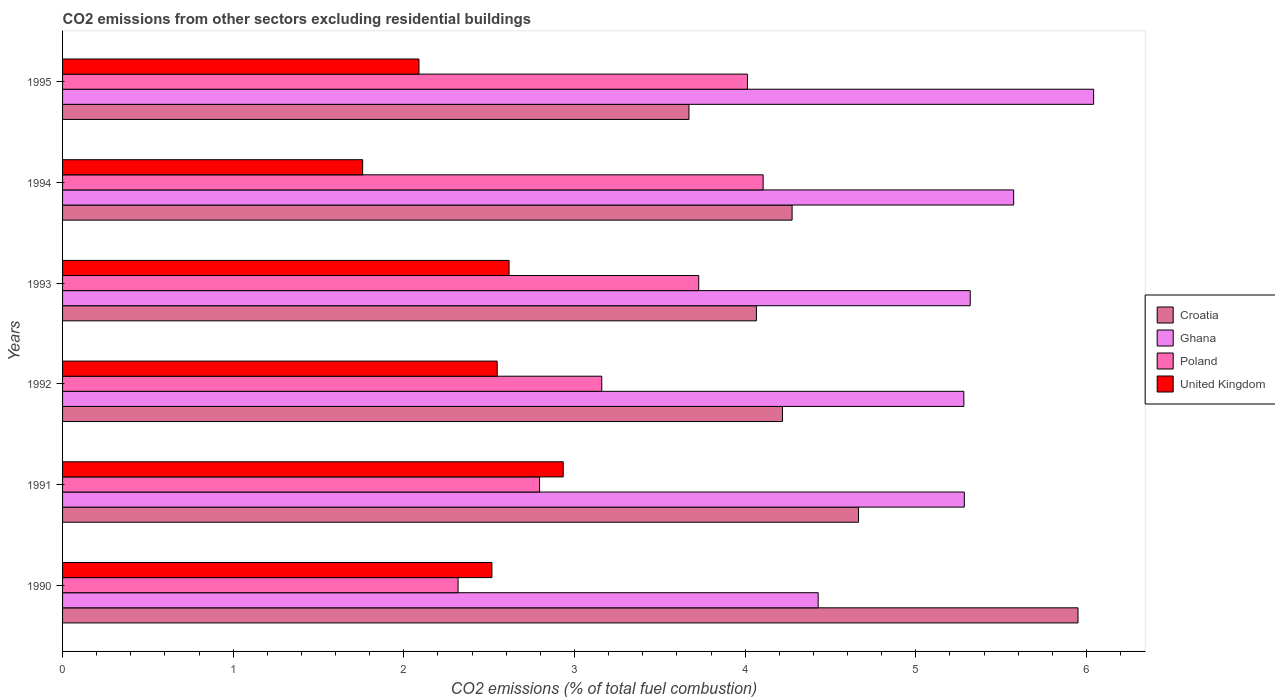How many different coloured bars are there?
Your response must be concise. 4. How many groups of bars are there?
Offer a very short reply. 6. How many bars are there on the 5th tick from the top?
Make the answer very short. 4. How many bars are there on the 4th tick from the bottom?
Offer a very short reply. 4. What is the total CO2 emitted in Ghana in 1992?
Ensure brevity in your answer.  5.28. Across all years, what is the maximum total CO2 emitted in Croatia?
Your answer should be compact. 5.95. Across all years, what is the minimum total CO2 emitted in Ghana?
Offer a very short reply. 4.43. In which year was the total CO2 emitted in Poland minimum?
Keep it short and to the point. 1990. What is the total total CO2 emitted in Ghana in the graph?
Ensure brevity in your answer.  31.93. What is the difference between the total CO2 emitted in Croatia in 1994 and that in 1995?
Your response must be concise. 0.6. What is the difference between the total CO2 emitted in United Kingdom in 1993 and the total CO2 emitted in Ghana in 1992?
Provide a succinct answer. -2.67. What is the average total CO2 emitted in Ghana per year?
Provide a succinct answer. 5.32. In the year 1992, what is the difference between the total CO2 emitted in Croatia and total CO2 emitted in United Kingdom?
Keep it short and to the point. 1.67. What is the ratio of the total CO2 emitted in Poland in 1992 to that in 1995?
Make the answer very short. 0.79. What is the difference between the highest and the second highest total CO2 emitted in Ghana?
Provide a short and direct response. 0.47. What is the difference between the highest and the lowest total CO2 emitted in Ghana?
Provide a succinct answer. 1.61. Is the sum of the total CO2 emitted in Ghana in 1992 and 1995 greater than the maximum total CO2 emitted in Poland across all years?
Make the answer very short. Yes. Is it the case that in every year, the sum of the total CO2 emitted in Poland and total CO2 emitted in Ghana is greater than the sum of total CO2 emitted in United Kingdom and total CO2 emitted in Croatia?
Offer a very short reply. Yes. What does the 4th bar from the top in 1990 represents?
Make the answer very short. Croatia. How many bars are there?
Your answer should be very brief. 24. How many years are there in the graph?
Keep it short and to the point. 6. What is the difference between two consecutive major ticks on the X-axis?
Give a very brief answer. 1. Are the values on the major ticks of X-axis written in scientific E-notation?
Give a very brief answer. No. Where does the legend appear in the graph?
Offer a very short reply. Center right. How are the legend labels stacked?
Give a very brief answer. Vertical. What is the title of the graph?
Keep it short and to the point. CO2 emissions from other sectors excluding residential buildings. What is the label or title of the X-axis?
Provide a succinct answer. CO2 emissions (% of total fuel combustion). What is the CO2 emissions (% of total fuel combustion) of Croatia in 1990?
Offer a terse response. 5.95. What is the CO2 emissions (% of total fuel combustion) in Ghana in 1990?
Provide a short and direct response. 4.43. What is the CO2 emissions (% of total fuel combustion) in Poland in 1990?
Your answer should be compact. 2.32. What is the CO2 emissions (% of total fuel combustion) in United Kingdom in 1990?
Give a very brief answer. 2.52. What is the CO2 emissions (% of total fuel combustion) in Croatia in 1991?
Give a very brief answer. 4.66. What is the CO2 emissions (% of total fuel combustion) of Ghana in 1991?
Your response must be concise. 5.28. What is the CO2 emissions (% of total fuel combustion) of Poland in 1991?
Your response must be concise. 2.8. What is the CO2 emissions (% of total fuel combustion) of United Kingdom in 1991?
Keep it short and to the point. 2.93. What is the CO2 emissions (% of total fuel combustion) of Croatia in 1992?
Provide a short and direct response. 4.22. What is the CO2 emissions (% of total fuel combustion) in Ghana in 1992?
Offer a terse response. 5.28. What is the CO2 emissions (% of total fuel combustion) in Poland in 1992?
Your response must be concise. 3.16. What is the CO2 emissions (% of total fuel combustion) in United Kingdom in 1992?
Ensure brevity in your answer.  2.55. What is the CO2 emissions (% of total fuel combustion) of Croatia in 1993?
Give a very brief answer. 4.07. What is the CO2 emissions (% of total fuel combustion) in Ghana in 1993?
Make the answer very short. 5.32. What is the CO2 emissions (% of total fuel combustion) of Poland in 1993?
Ensure brevity in your answer.  3.73. What is the CO2 emissions (% of total fuel combustion) of United Kingdom in 1993?
Your response must be concise. 2.62. What is the CO2 emissions (% of total fuel combustion) of Croatia in 1994?
Provide a short and direct response. 4.28. What is the CO2 emissions (% of total fuel combustion) in Ghana in 1994?
Offer a very short reply. 5.57. What is the CO2 emissions (% of total fuel combustion) in Poland in 1994?
Your answer should be very brief. 4.11. What is the CO2 emissions (% of total fuel combustion) in United Kingdom in 1994?
Give a very brief answer. 1.76. What is the CO2 emissions (% of total fuel combustion) in Croatia in 1995?
Provide a succinct answer. 3.67. What is the CO2 emissions (% of total fuel combustion) of Ghana in 1995?
Keep it short and to the point. 6.04. What is the CO2 emissions (% of total fuel combustion) in Poland in 1995?
Your answer should be very brief. 4.01. What is the CO2 emissions (% of total fuel combustion) of United Kingdom in 1995?
Ensure brevity in your answer.  2.09. Across all years, what is the maximum CO2 emissions (% of total fuel combustion) in Croatia?
Offer a very short reply. 5.95. Across all years, what is the maximum CO2 emissions (% of total fuel combustion) in Ghana?
Your response must be concise. 6.04. Across all years, what is the maximum CO2 emissions (% of total fuel combustion) of Poland?
Your response must be concise. 4.11. Across all years, what is the maximum CO2 emissions (% of total fuel combustion) in United Kingdom?
Provide a succinct answer. 2.93. Across all years, what is the minimum CO2 emissions (% of total fuel combustion) of Croatia?
Provide a succinct answer. 3.67. Across all years, what is the minimum CO2 emissions (% of total fuel combustion) of Ghana?
Give a very brief answer. 4.43. Across all years, what is the minimum CO2 emissions (% of total fuel combustion) in Poland?
Keep it short and to the point. 2.32. Across all years, what is the minimum CO2 emissions (% of total fuel combustion) in United Kingdom?
Ensure brevity in your answer.  1.76. What is the total CO2 emissions (% of total fuel combustion) of Croatia in the graph?
Provide a short and direct response. 26.85. What is the total CO2 emissions (% of total fuel combustion) in Ghana in the graph?
Make the answer very short. 31.93. What is the total CO2 emissions (% of total fuel combustion) of Poland in the graph?
Keep it short and to the point. 20.12. What is the total CO2 emissions (% of total fuel combustion) of United Kingdom in the graph?
Make the answer very short. 14.46. What is the difference between the CO2 emissions (% of total fuel combustion) of Croatia in 1990 and that in 1991?
Your response must be concise. 1.29. What is the difference between the CO2 emissions (% of total fuel combustion) of Ghana in 1990 and that in 1991?
Offer a terse response. -0.86. What is the difference between the CO2 emissions (% of total fuel combustion) of Poland in 1990 and that in 1991?
Provide a succinct answer. -0.48. What is the difference between the CO2 emissions (% of total fuel combustion) of United Kingdom in 1990 and that in 1991?
Ensure brevity in your answer.  -0.42. What is the difference between the CO2 emissions (% of total fuel combustion) in Croatia in 1990 and that in 1992?
Give a very brief answer. 1.73. What is the difference between the CO2 emissions (% of total fuel combustion) of Ghana in 1990 and that in 1992?
Provide a succinct answer. -0.85. What is the difference between the CO2 emissions (% of total fuel combustion) of Poland in 1990 and that in 1992?
Make the answer very short. -0.84. What is the difference between the CO2 emissions (% of total fuel combustion) of United Kingdom in 1990 and that in 1992?
Your response must be concise. -0.03. What is the difference between the CO2 emissions (% of total fuel combustion) of Croatia in 1990 and that in 1993?
Offer a very short reply. 1.88. What is the difference between the CO2 emissions (% of total fuel combustion) of Ghana in 1990 and that in 1993?
Offer a terse response. -0.89. What is the difference between the CO2 emissions (% of total fuel combustion) of Poland in 1990 and that in 1993?
Your answer should be very brief. -1.41. What is the difference between the CO2 emissions (% of total fuel combustion) of United Kingdom in 1990 and that in 1993?
Ensure brevity in your answer.  -0.1. What is the difference between the CO2 emissions (% of total fuel combustion) of Croatia in 1990 and that in 1994?
Provide a succinct answer. 1.68. What is the difference between the CO2 emissions (% of total fuel combustion) of Ghana in 1990 and that in 1994?
Your response must be concise. -1.15. What is the difference between the CO2 emissions (% of total fuel combustion) of Poland in 1990 and that in 1994?
Offer a very short reply. -1.79. What is the difference between the CO2 emissions (% of total fuel combustion) in United Kingdom in 1990 and that in 1994?
Your answer should be compact. 0.76. What is the difference between the CO2 emissions (% of total fuel combustion) in Croatia in 1990 and that in 1995?
Offer a terse response. 2.28. What is the difference between the CO2 emissions (% of total fuel combustion) of Ghana in 1990 and that in 1995?
Keep it short and to the point. -1.61. What is the difference between the CO2 emissions (% of total fuel combustion) of Poland in 1990 and that in 1995?
Ensure brevity in your answer.  -1.7. What is the difference between the CO2 emissions (% of total fuel combustion) of United Kingdom in 1990 and that in 1995?
Give a very brief answer. 0.43. What is the difference between the CO2 emissions (% of total fuel combustion) in Croatia in 1991 and that in 1992?
Your response must be concise. 0.45. What is the difference between the CO2 emissions (% of total fuel combustion) in Ghana in 1991 and that in 1992?
Offer a terse response. 0. What is the difference between the CO2 emissions (% of total fuel combustion) in Poland in 1991 and that in 1992?
Offer a terse response. -0.36. What is the difference between the CO2 emissions (% of total fuel combustion) of United Kingdom in 1991 and that in 1992?
Offer a very short reply. 0.39. What is the difference between the CO2 emissions (% of total fuel combustion) of Croatia in 1991 and that in 1993?
Ensure brevity in your answer.  0.6. What is the difference between the CO2 emissions (% of total fuel combustion) in Ghana in 1991 and that in 1993?
Provide a succinct answer. -0.03. What is the difference between the CO2 emissions (% of total fuel combustion) in Poland in 1991 and that in 1993?
Your answer should be compact. -0.93. What is the difference between the CO2 emissions (% of total fuel combustion) in United Kingdom in 1991 and that in 1993?
Offer a terse response. 0.32. What is the difference between the CO2 emissions (% of total fuel combustion) of Croatia in 1991 and that in 1994?
Your response must be concise. 0.39. What is the difference between the CO2 emissions (% of total fuel combustion) in Ghana in 1991 and that in 1994?
Provide a short and direct response. -0.29. What is the difference between the CO2 emissions (% of total fuel combustion) in Poland in 1991 and that in 1994?
Offer a terse response. -1.31. What is the difference between the CO2 emissions (% of total fuel combustion) in United Kingdom in 1991 and that in 1994?
Your response must be concise. 1.18. What is the difference between the CO2 emissions (% of total fuel combustion) in Croatia in 1991 and that in 1995?
Your answer should be compact. 0.99. What is the difference between the CO2 emissions (% of total fuel combustion) of Ghana in 1991 and that in 1995?
Offer a terse response. -0.76. What is the difference between the CO2 emissions (% of total fuel combustion) in Poland in 1991 and that in 1995?
Your answer should be compact. -1.22. What is the difference between the CO2 emissions (% of total fuel combustion) of United Kingdom in 1991 and that in 1995?
Provide a succinct answer. 0.85. What is the difference between the CO2 emissions (% of total fuel combustion) of Croatia in 1992 and that in 1993?
Keep it short and to the point. 0.15. What is the difference between the CO2 emissions (% of total fuel combustion) in Ghana in 1992 and that in 1993?
Your answer should be very brief. -0.04. What is the difference between the CO2 emissions (% of total fuel combustion) of Poland in 1992 and that in 1993?
Give a very brief answer. -0.57. What is the difference between the CO2 emissions (% of total fuel combustion) in United Kingdom in 1992 and that in 1993?
Offer a terse response. -0.07. What is the difference between the CO2 emissions (% of total fuel combustion) of Croatia in 1992 and that in 1994?
Your answer should be compact. -0.06. What is the difference between the CO2 emissions (% of total fuel combustion) of Ghana in 1992 and that in 1994?
Provide a short and direct response. -0.29. What is the difference between the CO2 emissions (% of total fuel combustion) of Poland in 1992 and that in 1994?
Give a very brief answer. -0.95. What is the difference between the CO2 emissions (% of total fuel combustion) in United Kingdom in 1992 and that in 1994?
Your response must be concise. 0.79. What is the difference between the CO2 emissions (% of total fuel combustion) of Croatia in 1992 and that in 1995?
Provide a succinct answer. 0.55. What is the difference between the CO2 emissions (% of total fuel combustion) of Ghana in 1992 and that in 1995?
Your answer should be very brief. -0.76. What is the difference between the CO2 emissions (% of total fuel combustion) in Poland in 1992 and that in 1995?
Provide a succinct answer. -0.85. What is the difference between the CO2 emissions (% of total fuel combustion) in United Kingdom in 1992 and that in 1995?
Make the answer very short. 0.46. What is the difference between the CO2 emissions (% of total fuel combustion) in Croatia in 1993 and that in 1994?
Ensure brevity in your answer.  -0.21. What is the difference between the CO2 emissions (% of total fuel combustion) of Ghana in 1993 and that in 1994?
Give a very brief answer. -0.25. What is the difference between the CO2 emissions (% of total fuel combustion) in Poland in 1993 and that in 1994?
Keep it short and to the point. -0.38. What is the difference between the CO2 emissions (% of total fuel combustion) in United Kingdom in 1993 and that in 1994?
Offer a terse response. 0.86. What is the difference between the CO2 emissions (% of total fuel combustion) of Croatia in 1993 and that in 1995?
Keep it short and to the point. 0.4. What is the difference between the CO2 emissions (% of total fuel combustion) of Ghana in 1993 and that in 1995?
Keep it short and to the point. -0.72. What is the difference between the CO2 emissions (% of total fuel combustion) in Poland in 1993 and that in 1995?
Ensure brevity in your answer.  -0.29. What is the difference between the CO2 emissions (% of total fuel combustion) in United Kingdom in 1993 and that in 1995?
Your response must be concise. 0.53. What is the difference between the CO2 emissions (% of total fuel combustion) of Croatia in 1994 and that in 1995?
Make the answer very short. 0.6. What is the difference between the CO2 emissions (% of total fuel combustion) in Ghana in 1994 and that in 1995?
Your response must be concise. -0.47. What is the difference between the CO2 emissions (% of total fuel combustion) in Poland in 1994 and that in 1995?
Make the answer very short. 0.09. What is the difference between the CO2 emissions (% of total fuel combustion) in United Kingdom in 1994 and that in 1995?
Your response must be concise. -0.33. What is the difference between the CO2 emissions (% of total fuel combustion) of Croatia in 1990 and the CO2 emissions (% of total fuel combustion) of Ghana in 1991?
Keep it short and to the point. 0.67. What is the difference between the CO2 emissions (% of total fuel combustion) in Croatia in 1990 and the CO2 emissions (% of total fuel combustion) in Poland in 1991?
Offer a terse response. 3.16. What is the difference between the CO2 emissions (% of total fuel combustion) in Croatia in 1990 and the CO2 emissions (% of total fuel combustion) in United Kingdom in 1991?
Give a very brief answer. 3.02. What is the difference between the CO2 emissions (% of total fuel combustion) of Ghana in 1990 and the CO2 emissions (% of total fuel combustion) of Poland in 1991?
Your answer should be compact. 1.63. What is the difference between the CO2 emissions (% of total fuel combustion) in Ghana in 1990 and the CO2 emissions (% of total fuel combustion) in United Kingdom in 1991?
Give a very brief answer. 1.49. What is the difference between the CO2 emissions (% of total fuel combustion) in Poland in 1990 and the CO2 emissions (% of total fuel combustion) in United Kingdom in 1991?
Your answer should be very brief. -0.62. What is the difference between the CO2 emissions (% of total fuel combustion) of Croatia in 1990 and the CO2 emissions (% of total fuel combustion) of Ghana in 1992?
Keep it short and to the point. 0.67. What is the difference between the CO2 emissions (% of total fuel combustion) in Croatia in 1990 and the CO2 emissions (% of total fuel combustion) in Poland in 1992?
Provide a short and direct response. 2.79. What is the difference between the CO2 emissions (% of total fuel combustion) in Croatia in 1990 and the CO2 emissions (% of total fuel combustion) in United Kingdom in 1992?
Your answer should be compact. 3.4. What is the difference between the CO2 emissions (% of total fuel combustion) in Ghana in 1990 and the CO2 emissions (% of total fuel combustion) in Poland in 1992?
Your answer should be very brief. 1.27. What is the difference between the CO2 emissions (% of total fuel combustion) of Ghana in 1990 and the CO2 emissions (% of total fuel combustion) of United Kingdom in 1992?
Offer a terse response. 1.88. What is the difference between the CO2 emissions (% of total fuel combustion) in Poland in 1990 and the CO2 emissions (% of total fuel combustion) in United Kingdom in 1992?
Ensure brevity in your answer.  -0.23. What is the difference between the CO2 emissions (% of total fuel combustion) in Croatia in 1990 and the CO2 emissions (% of total fuel combustion) in Ghana in 1993?
Provide a short and direct response. 0.63. What is the difference between the CO2 emissions (% of total fuel combustion) of Croatia in 1990 and the CO2 emissions (% of total fuel combustion) of Poland in 1993?
Provide a succinct answer. 2.22. What is the difference between the CO2 emissions (% of total fuel combustion) in Croatia in 1990 and the CO2 emissions (% of total fuel combustion) in United Kingdom in 1993?
Keep it short and to the point. 3.33. What is the difference between the CO2 emissions (% of total fuel combustion) of Ghana in 1990 and the CO2 emissions (% of total fuel combustion) of United Kingdom in 1993?
Your answer should be very brief. 1.81. What is the difference between the CO2 emissions (% of total fuel combustion) of Poland in 1990 and the CO2 emissions (% of total fuel combustion) of United Kingdom in 1993?
Your response must be concise. -0.3. What is the difference between the CO2 emissions (% of total fuel combustion) in Croatia in 1990 and the CO2 emissions (% of total fuel combustion) in Ghana in 1994?
Offer a terse response. 0.38. What is the difference between the CO2 emissions (% of total fuel combustion) in Croatia in 1990 and the CO2 emissions (% of total fuel combustion) in Poland in 1994?
Provide a succinct answer. 1.84. What is the difference between the CO2 emissions (% of total fuel combustion) in Croatia in 1990 and the CO2 emissions (% of total fuel combustion) in United Kingdom in 1994?
Ensure brevity in your answer.  4.19. What is the difference between the CO2 emissions (% of total fuel combustion) in Ghana in 1990 and the CO2 emissions (% of total fuel combustion) in Poland in 1994?
Provide a succinct answer. 0.32. What is the difference between the CO2 emissions (% of total fuel combustion) of Ghana in 1990 and the CO2 emissions (% of total fuel combustion) of United Kingdom in 1994?
Give a very brief answer. 2.67. What is the difference between the CO2 emissions (% of total fuel combustion) of Poland in 1990 and the CO2 emissions (% of total fuel combustion) of United Kingdom in 1994?
Offer a terse response. 0.56. What is the difference between the CO2 emissions (% of total fuel combustion) of Croatia in 1990 and the CO2 emissions (% of total fuel combustion) of Ghana in 1995?
Make the answer very short. -0.09. What is the difference between the CO2 emissions (% of total fuel combustion) of Croatia in 1990 and the CO2 emissions (% of total fuel combustion) of Poland in 1995?
Provide a succinct answer. 1.94. What is the difference between the CO2 emissions (% of total fuel combustion) of Croatia in 1990 and the CO2 emissions (% of total fuel combustion) of United Kingdom in 1995?
Keep it short and to the point. 3.86. What is the difference between the CO2 emissions (% of total fuel combustion) in Ghana in 1990 and the CO2 emissions (% of total fuel combustion) in Poland in 1995?
Provide a succinct answer. 0.41. What is the difference between the CO2 emissions (% of total fuel combustion) of Ghana in 1990 and the CO2 emissions (% of total fuel combustion) of United Kingdom in 1995?
Your answer should be very brief. 2.34. What is the difference between the CO2 emissions (% of total fuel combustion) of Poland in 1990 and the CO2 emissions (% of total fuel combustion) of United Kingdom in 1995?
Offer a terse response. 0.23. What is the difference between the CO2 emissions (% of total fuel combustion) in Croatia in 1991 and the CO2 emissions (% of total fuel combustion) in Ghana in 1992?
Your answer should be very brief. -0.62. What is the difference between the CO2 emissions (% of total fuel combustion) in Croatia in 1991 and the CO2 emissions (% of total fuel combustion) in Poland in 1992?
Your answer should be compact. 1.5. What is the difference between the CO2 emissions (% of total fuel combustion) of Croatia in 1991 and the CO2 emissions (% of total fuel combustion) of United Kingdom in 1992?
Provide a short and direct response. 2.12. What is the difference between the CO2 emissions (% of total fuel combustion) in Ghana in 1991 and the CO2 emissions (% of total fuel combustion) in Poland in 1992?
Make the answer very short. 2.12. What is the difference between the CO2 emissions (% of total fuel combustion) in Ghana in 1991 and the CO2 emissions (% of total fuel combustion) in United Kingdom in 1992?
Offer a very short reply. 2.74. What is the difference between the CO2 emissions (% of total fuel combustion) of Poland in 1991 and the CO2 emissions (% of total fuel combustion) of United Kingdom in 1992?
Ensure brevity in your answer.  0.25. What is the difference between the CO2 emissions (% of total fuel combustion) of Croatia in 1991 and the CO2 emissions (% of total fuel combustion) of Ghana in 1993?
Ensure brevity in your answer.  -0.65. What is the difference between the CO2 emissions (% of total fuel combustion) in Croatia in 1991 and the CO2 emissions (% of total fuel combustion) in Poland in 1993?
Make the answer very short. 0.94. What is the difference between the CO2 emissions (% of total fuel combustion) of Croatia in 1991 and the CO2 emissions (% of total fuel combustion) of United Kingdom in 1993?
Provide a succinct answer. 2.05. What is the difference between the CO2 emissions (% of total fuel combustion) in Ghana in 1991 and the CO2 emissions (% of total fuel combustion) in Poland in 1993?
Keep it short and to the point. 1.56. What is the difference between the CO2 emissions (% of total fuel combustion) in Ghana in 1991 and the CO2 emissions (% of total fuel combustion) in United Kingdom in 1993?
Offer a very short reply. 2.67. What is the difference between the CO2 emissions (% of total fuel combustion) in Poland in 1991 and the CO2 emissions (% of total fuel combustion) in United Kingdom in 1993?
Offer a very short reply. 0.18. What is the difference between the CO2 emissions (% of total fuel combustion) in Croatia in 1991 and the CO2 emissions (% of total fuel combustion) in Ghana in 1994?
Your answer should be very brief. -0.91. What is the difference between the CO2 emissions (% of total fuel combustion) in Croatia in 1991 and the CO2 emissions (% of total fuel combustion) in Poland in 1994?
Provide a short and direct response. 0.56. What is the difference between the CO2 emissions (% of total fuel combustion) of Croatia in 1991 and the CO2 emissions (% of total fuel combustion) of United Kingdom in 1994?
Your answer should be very brief. 2.91. What is the difference between the CO2 emissions (% of total fuel combustion) in Ghana in 1991 and the CO2 emissions (% of total fuel combustion) in Poland in 1994?
Make the answer very short. 1.18. What is the difference between the CO2 emissions (% of total fuel combustion) of Ghana in 1991 and the CO2 emissions (% of total fuel combustion) of United Kingdom in 1994?
Your answer should be compact. 3.53. What is the difference between the CO2 emissions (% of total fuel combustion) in Poland in 1991 and the CO2 emissions (% of total fuel combustion) in United Kingdom in 1994?
Make the answer very short. 1.04. What is the difference between the CO2 emissions (% of total fuel combustion) of Croatia in 1991 and the CO2 emissions (% of total fuel combustion) of Ghana in 1995?
Your response must be concise. -1.38. What is the difference between the CO2 emissions (% of total fuel combustion) in Croatia in 1991 and the CO2 emissions (% of total fuel combustion) in Poland in 1995?
Provide a short and direct response. 0.65. What is the difference between the CO2 emissions (% of total fuel combustion) in Croatia in 1991 and the CO2 emissions (% of total fuel combustion) in United Kingdom in 1995?
Your answer should be very brief. 2.58. What is the difference between the CO2 emissions (% of total fuel combustion) in Ghana in 1991 and the CO2 emissions (% of total fuel combustion) in Poland in 1995?
Provide a succinct answer. 1.27. What is the difference between the CO2 emissions (% of total fuel combustion) in Ghana in 1991 and the CO2 emissions (% of total fuel combustion) in United Kingdom in 1995?
Give a very brief answer. 3.2. What is the difference between the CO2 emissions (% of total fuel combustion) of Poland in 1991 and the CO2 emissions (% of total fuel combustion) of United Kingdom in 1995?
Provide a succinct answer. 0.71. What is the difference between the CO2 emissions (% of total fuel combustion) of Croatia in 1992 and the CO2 emissions (% of total fuel combustion) of Ghana in 1993?
Give a very brief answer. -1.1. What is the difference between the CO2 emissions (% of total fuel combustion) of Croatia in 1992 and the CO2 emissions (% of total fuel combustion) of Poland in 1993?
Offer a terse response. 0.49. What is the difference between the CO2 emissions (% of total fuel combustion) of Croatia in 1992 and the CO2 emissions (% of total fuel combustion) of United Kingdom in 1993?
Keep it short and to the point. 1.6. What is the difference between the CO2 emissions (% of total fuel combustion) of Ghana in 1992 and the CO2 emissions (% of total fuel combustion) of Poland in 1993?
Your response must be concise. 1.55. What is the difference between the CO2 emissions (% of total fuel combustion) of Ghana in 1992 and the CO2 emissions (% of total fuel combustion) of United Kingdom in 1993?
Make the answer very short. 2.67. What is the difference between the CO2 emissions (% of total fuel combustion) in Poland in 1992 and the CO2 emissions (% of total fuel combustion) in United Kingdom in 1993?
Your response must be concise. 0.54. What is the difference between the CO2 emissions (% of total fuel combustion) of Croatia in 1992 and the CO2 emissions (% of total fuel combustion) of Ghana in 1994?
Offer a terse response. -1.35. What is the difference between the CO2 emissions (% of total fuel combustion) in Croatia in 1992 and the CO2 emissions (% of total fuel combustion) in Poland in 1994?
Your answer should be compact. 0.11. What is the difference between the CO2 emissions (% of total fuel combustion) of Croatia in 1992 and the CO2 emissions (% of total fuel combustion) of United Kingdom in 1994?
Offer a very short reply. 2.46. What is the difference between the CO2 emissions (% of total fuel combustion) of Ghana in 1992 and the CO2 emissions (% of total fuel combustion) of Poland in 1994?
Your answer should be very brief. 1.18. What is the difference between the CO2 emissions (% of total fuel combustion) of Ghana in 1992 and the CO2 emissions (% of total fuel combustion) of United Kingdom in 1994?
Your answer should be very brief. 3.52. What is the difference between the CO2 emissions (% of total fuel combustion) of Poland in 1992 and the CO2 emissions (% of total fuel combustion) of United Kingdom in 1994?
Your answer should be very brief. 1.4. What is the difference between the CO2 emissions (% of total fuel combustion) in Croatia in 1992 and the CO2 emissions (% of total fuel combustion) in Ghana in 1995?
Your answer should be compact. -1.82. What is the difference between the CO2 emissions (% of total fuel combustion) of Croatia in 1992 and the CO2 emissions (% of total fuel combustion) of Poland in 1995?
Keep it short and to the point. 0.21. What is the difference between the CO2 emissions (% of total fuel combustion) in Croatia in 1992 and the CO2 emissions (% of total fuel combustion) in United Kingdom in 1995?
Make the answer very short. 2.13. What is the difference between the CO2 emissions (% of total fuel combustion) of Ghana in 1992 and the CO2 emissions (% of total fuel combustion) of Poland in 1995?
Ensure brevity in your answer.  1.27. What is the difference between the CO2 emissions (% of total fuel combustion) in Ghana in 1992 and the CO2 emissions (% of total fuel combustion) in United Kingdom in 1995?
Offer a terse response. 3.19. What is the difference between the CO2 emissions (% of total fuel combustion) in Poland in 1992 and the CO2 emissions (% of total fuel combustion) in United Kingdom in 1995?
Offer a very short reply. 1.07. What is the difference between the CO2 emissions (% of total fuel combustion) in Croatia in 1993 and the CO2 emissions (% of total fuel combustion) in Ghana in 1994?
Give a very brief answer. -1.51. What is the difference between the CO2 emissions (% of total fuel combustion) of Croatia in 1993 and the CO2 emissions (% of total fuel combustion) of Poland in 1994?
Offer a terse response. -0.04. What is the difference between the CO2 emissions (% of total fuel combustion) of Croatia in 1993 and the CO2 emissions (% of total fuel combustion) of United Kingdom in 1994?
Provide a succinct answer. 2.31. What is the difference between the CO2 emissions (% of total fuel combustion) of Ghana in 1993 and the CO2 emissions (% of total fuel combustion) of Poland in 1994?
Provide a short and direct response. 1.21. What is the difference between the CO2 emissions (% of total fuel combustion) in Ghana in 1993 and the CO2 emissions (% of total fuel combustion) in United Kingdom in 1994?
Provide a succinct answer. 3.56. What is the difference between the CO2 emissions (% of total fuel combustion) in Poland in 1993 and the CO2 emissions (% of total fuel combustion) in United Kingdom in 1994?
Your answer should be very brief. 1.97. What is the difference between the CO2 emissions (% of total fuel combustion) of Croatia in 1993 and the CO2 emissions (% of total fuel combustion) of Ghana in 1995?
Your response must be concise. -1.98. What is the difference between the CO2 emissions (% of total fuel combustion) in Croatia in 1993 and the CO2 emissions (% of total fuel combustion) in Poland in 1995?
Provide a short and direct response. 0.05. What is the difference between the CO2 emissions (% of total fuel combustion) in Croatia in 1993 and the CO2 emissions (% of total fuel combustion) in United Kingdom in 1995?
Keep it short and to the point. 1.98. What is the difference between the CO2 emissions (% of total fuel combustion) in Ghana in 1993 and the CO2 emissions (% of total fuel combustion) in Poland in 1995?
Your response must be concise. 1.31. What is the difference between the CO2 emissions (% of total fuel combustion) in Ghana in 1993 and the CO2 emissions (% of total fuel combustion) in United Kingdom in 1995?
Make the answer very short. 3.23. What is the difference between the CO2 emissions (% of total fuel combustion) of Poland in 1993 and the CO2 emissions (% of total fuel combustion) of United Kingdom in 1995?
Provide a succinct answer. 1.64. What is the difference between the CO2 emissions (% of total fuel combustion) in Croatia in 1994 and the CO2 emissions (% of total fuel combustion) in Ghana in 1995?
Your answer should be very brief. -1.77. What is the difference between the CO2 emissions (% of total fuel combustion) of Croatia in 1994 and the CO2 emissions (% of total fuel combustion) of Poland in 1995?
Ensure brevity in your answer.  0.26. What is the difference between the CO2 emissions (% of total fuel combustion) of Croatia in 1994 and the CO2 emissions (% of total fuel combustion) of United Kingdom in 1995?
Give a very brief answer. 2.19. What is the difference between the CO2 emissions (% of total fuel combustion) in Ghana in 1994 and the CO2 emissions (% of total fuel combustion) in Poland in 1995?
Provide a short and direct response. 1.56. What is the difference between the CO2 emissions (% of total fuel combustion) in Ghana in 1994 and the CO2 emissions (% of total fuel combustion) in United Kingdom in 1995?
Keep it short and to the point. 3.49. What is the difference between the CO2 emissions (% of total fuel combustion) in Poland in 1994 and the CO2 emissions (% of total fuel combustion) in United Kingdom in 1995?
Offer a terse response. 2.02. What is the average CO2 emissions (% of total fuel combustion) in Croatia per year?
Your answer should be very brief. 4.47. What is the average CO2 emissions (% of total fuel combustion) of Ghana per year?
Your answer should be very brief. 5.32. What is the average CO2 emissions (% of total fuel combustion) of Poland per year?
Your answer should be very brief. 3.35. What is the average CO2 emissions (% of total fuel combustion) in United Kingdom per year?
Make the answer very short. 2.41. In the year 1990, what is the difference between the CO2 emissions (% of total fuel combustion) in Croatia and CO2 emissions (% of total fuel combustion) in Ghana?
Make the answer very short. 1.52. In the year 1990, what is the difference between the CO2 emissions (% of total fuel combustion) in Croatia and CO2 emissions (% of total fuel combustion) in Poland?
Give a very brief answer. 3.63. In the year 1990, what is the difference between the CO2 emissions (% of total fuel combustion) in Croatia and CO2 emissions (% of total fuel combustion) in United Kingdom?
Keep it short and to the point. 3.43. In the year 1990, what is the difference between the CO2 emissions (% of total fuel combustion) of Ghana and CO2 emissions (% of total fuel combustion) of Poland?
Give a very brief answer. 2.11. In the year 1990, what is the difference between the CO2 emissions (% of total fuel combustion) of Ghana and CO2 emissions (% of total fuel combustion) of United Kingdom?
Provide a short and direct response. 1.91. In the year 1990, what is the difference between the CO2 emissions (% of total fuel combustion) in Poland and CO2 emissions (% of total fuel combustion) in United Kingdom?
Your answer should be compact. -0.2. In the year 1991, what is the difference between the CO2 emissions (% of total fuel combustion) in Croatia and CO2 emissions (% of total fuel combustion) in Ghana?
Provide a short and direct response. -0.62. In the year 1991, what is the difference between the CO2 emissions (% of total fuel combustion) in Croatia and CO2 emissions (% of total fuel combustion) in Poland?
Offer a very short reply. 1.87. In the year 1991, what is the difference between the CO2 emissions (% of total fuel combustion) in Croatia and CO2 emissions (% of total fuel combustion) in United Kingdom?
Your answer should be very brief. 1.73. In the year 1991, what is the difference between the CO2 emissions (% of total fuel combustion) in Ghana and CO2 emissions (% of total fuel combustion) in Poland?
Your answer should be compact. 2.49. In the year 1991, what is the difference between the CO2 emissions (% of total fuel combustion) of Ghana and CO2 emissions (% of total fuel combustion) of United Kingdom?
Provide a short and direct response. 2.35. In the year 1991, what is the difference between the CO2 emissions (% of total fuel combustion) of Poland and CO2 emissions (% of total fuel combustion) of United Kingdom?
Give a very brief answer. -0.14. In the year 1992, what is the difference between the CO2 emissions (% of total fuel combustion) in Croatia and CO2 emissions (% of total fuel combustion) in Ghana?
Keep it short and to the point. -1.06. In the year 1992, what is the difference between the CO2 emissions (% of total fuel combustion) of Croatia and CO2 emissions (% of total fuel combustion) of Poland?
Provide a short and direct response. 1.06. In the year 1992, what is the difference between the CO2 emissions (% of total fuel combustion) in Croatia and CO2 emissions (% of total fuel combustion) in United Kingdom?
Your answer should be very brief. 1.67. In the year 1992, what is the difference between the CO2 emissions (% of total fuel combustion) in Ghana and CO2 emissions (% of total fuel combustion) in Poland?
Keep it short and to the point. 2.12. In the year 1992, what is the difference between the CO2 emissions (% of total fuel combustion) of Ghana and CO2 emissions (% of total fuel combustion) of United Kingdom?
Your response must be concise. 2.73. In the year 1992, what is the difference between the CO2 emissions (% of total fuel combustion) in Poland and CO2 emissions (% of total fuel combustion) in United Kingdom?
Keep it short and to the point. 0.61. In the year 1993, what is the difference between the CO2 emissions (% of total fuel combustion) in Croatia and CO2 emissions (% of total fuel combustion) in Ghana?
Keep it short and to the point. -1.25. In the year 1993, what is the difference between the CO2 emissions (% of total fuel combustion) of Croatia and CO2 emissions (% of total fuel combustion) of Poland?
Your answer should be compact. 0.34. In the year 1993, what is the difference between the CO2 emissions (% of total fuel combustion) of Croatia and CO2 emissions (% of total fuel combustion) of United Kingdom?
Provide a short and direct response. 1.45. In the year 1993, what is the difference between the CO2 emissions (% of total fuel combustion) of Ghana and CO2 emissions (% of total fuel combustion) of Poland?
Make the answer very short. 1.59. In the year 1993, what is the difference between the CO2 emissions (% of total fuel combustion) in Ghana and CO2 emissions (% of total fuel combustion) in United Kingdom?
Give a very brief answer. 2.7. In the year 1993, what is the difference between the CO2 emissions (% of total fuel combustion) of Poland and CO2 emissions (% of total fuel combustion) of United Kingdom?
Ensure brevity in your answer.  1.11. In the year 1994, what is the difference between the CO2 emissions (% of total fuel combustion) of Croatia and CO2 emissions (% of total fuel combustion) of Ghana?
Make the answer very short. -1.3. In the year 1994, what is the difference between the CO2 emissions (% of total fuel combustion) in Croatia and CO2 emissions (% of total fuel combustion) in Poland?
Keep it short and to the point. 0.17. In the year 1994, what is the difference between the CO2 emissions (% of total fuel combustion) in Croatia and CO2 emissions (% of total fuel combustion) in United Kingdom?
Offer a very short reply. 2.52. In the year 1994, what is the difference between the CO2 emissions (% of total fuel combustion) in Ghana and CO2 emissions (% of total fuel combustion) in Poland?
Make the answer very short. 1.47. In the year 1994, what is the difference between the CO2 emissions (% of total fuel combustion) of Ghana and CO2 emissions (% of total fuel combustion) of United Kingdom?
Your answer should be compact. 3.82. In the year 1994, what is the difference between the CO2 emissions (% of total fuel combustion) of Poland and CO2 emissions (% of total fuel combustion) of United Kingdom?
Your response must be concise. 2.35. In the year 1995, what is the difference between the CO2 emissions (% of total fuel combustion) of Croatia and CO2 emissions (% of total fuel combustion) of Ghana?
Make the answer very short. -2.37. In the year 1995, what is the difference between the CO2 emissions (% of total fuel combustion) of Croatia and CO2 emissions (% of total fuel combustion) of Poland?
Your response must be concise. -0.34. In the year 1995, what is the difference between the CO2 emissions (% of total fuel combustion) in Croatia and CO2 emissions (% of total fuel combustion) in United Kingdom?
Make the answer very short. 1.58. In the year 1995, what is the difference between the CO2 emissions (% of total fuel combustion) in Ghana and CO2 emissions (% of total fuel combustion) in Poland?
Your answer should be very brief. 2.03. In the year 1995, what is the difference between the CO2 emissions (% of total fuel combustion) in Ghana and CO2 emissions (% of total fuel combustion) in United Kingdom?
Offer a terse response. 3.95. In the year 1995, what is the difference between the CO2 emissions (% of total fuel combustion) of Poland and CO2 emissions (% of total fuel combustion) of United Kingdom?
Offer a terse response. 1.92. What is the ratio of the CO2 emissions (% of total fuel combustion) in Croatia in 1990 to that in 1991?
Provide a short and direct response. 1.28. What is the ratio of the CO2 emissions (% of total fuel combustion) of Ghana in 1990 to that in 1991?
Provide a short and direct response. 0.84. What is the ratio of the CO2 emissions (% of total fuel combustion) in Poland in 1990 to that in 1991?
Provide a short and direct response. 0.83. What is the ratio of the CO2 emissions (% of total fuel combustion) in United Kingdom in 1990 to that in 1991?
Your response must be concise. 0.86. What is the ratio of the CO2 emissions (% of total fuel combustion) in Croatia in 1990 to that in 1992?
Make the answer very short. 1.41. What is the ratio of the CO2 emissions (% of total fuel combustion) in Ghana in 1990 to that in 1992?
Your answer should be compact. 0.84. What is the ratio of the CO2 emissions (% of total fuel combustion) in Poland in 1990 to that in 1992?
Your response must be concise. 0.73. What is the ratio of the CO2 emissions (% of total fuel combustion) of United Kingdom in 1990 to that in 1992?
Your answer should be compact. 0.99. What is the ratio of the CO2 emissions (% of total fuel combustion) of Croatia in 1990 to that in 1993?
Your answer should be compact. 1.46. What is the ratio of the CO2 emissions (% of total fuel combustion) of Ghana in 1990 to that in 1993?
Offer a terse response. 0.83. What is the ratio of the CO2 emissions (% of total fuel combustion) in Poland in 1990 to that in 1993?
Provide a succinct answer. 0.62. What is the ratio of the CO2 emissions (% of total fuel combustion) in United Kingdom in 1990 to that in 1993?
Ensure brevity in your answer.  0.96. What is the ratio of the CO2 emissions (% of total fuel combustion) of Croatia in 1990 to that in 1994?
Keep it short and to the point. 1.39. What is the ratio of the CO2 emissions (% of total fuel combustion) of Ghana in 1990 to that in 1994?
Ensure brevity in your answer.  0.79. What is the ratio of the CO2 emissions (% of total fuel combustion) of Poland in 1990 to that in 1994?
Offer a terse response. 0.56. What is the ratio of the CO2 emissions (% of total fuel combustion) in United Kingdom in 1990 to that in 1994?
Your response must be concise. 1.43. What is the ratio of the CO2 emissions (% of total fuel combustion) of Croatia in 1990 to that in 1995?
Your answer should be very brief. 1.62. What is the ratio of the CO2 emissions (% of total fuel combustion) in Ghana in 1990 to that in 1995?
Your response must be concise. 0.73. What is the ratio of the CO2 emissions (% of total fuel combustion) of Poland in 1990 to that in 1995?
Keep it short and to the point. 0.58. What is the ratio of the CO2 emissions (% of total fuel combustion) in United Kingdom in 1990 to that in 1995?
Keep it short and to the point. 1.2. What is the ratio of the CO2 emissions (% of total fuel combustion) of Croatia in 1991 to that in 1992?
Your answer should be compact. 1.11. What is the ratio of the CO2 emissions (% of total fuel combustion) of Ghana in 1991 to that in 1992?
Make the answer very short. 1. What is the ratio of the CO2 emissions (% of total fuel combustion) in Poland in 1991 to that in 1992?
Ensure brevity in your answer.  0.88. What is the ratio of the CO2 emissions (% of total fuel combustion) of United Kingdom in 1991 to that in 1992?
Keep it short and to the point. 1.15. What is the ratio of the CO2 emissions (% of total fuel combustion) of Croatia in 1991 to that in 1993?
Your answer should be compact. 1.15. What is the ratio of the CO2 emissions (% of total fuel combustion) of Poland in 1991 to that in 1993?
Keep it short and to the point. 0.75. What is the ratio of the CO2 emissions (% of total fuel combustion) of United Kingdom in 1991 to that in 1993?
Keep it short and to the point. 1.12. What is the ratio of the CO2 emissions (% of total fuel combustion) of Croatia in 1991 to that in 1994?
Offer a terse response. 1.09. What is the ratio of the CO2 emissions (% of total fuel combustion) in Ghana in 1991 to that in 1994?
Your answer should be compact. 0.95. What is the ratio of the CO2 emissions (% of total fuel combustion) in Poland in 1991 to that in 1994?
Your answer should be compact. 0.68. What is the ratio of the CO2 emissions (% of total fuel combustion) in United Kingdom in 1991 to that in 1994?
Offer a terse response. 1.67. What is the ratio of the CO2 emissions (% of total fuel combustion) of Croatia in 1991 to that in 1995?
Your answer should be very brief. 1.27. What is the ratio of the CO2 emissions (% of total fuel combustion) of Ghana in 1991 to that in 1995?
Give a very brief answer. 0.87. What is the ratio of the CO2 emissions (% of total fuel combustion) of Poland in 1991 to that in 1995?
Provide a succinct answer. 0.7. What is the ratio of the CO2 emissions (% of total fuel combustion) of United Kingdom in 1991 to that in 1995?
Provide a short and direct response. 1.4. What is the ratio of the CO2 emissions (% of total fuel combustion) of Croatia in 1992 to that in 1993?
Offer a terse response. 1.04. What is the ratio of the CO2 emissions (% of total fuel combustion) in Ghana in 1992 to that in 1993?
Provide a short and direct response. 0.99. What is the ratio of the CO2 emissions (% of total fuel combustion) in Poland in 1992 to that in 1993?
Offer a terse response. 0.85. What is the ratio of the CO2 emissions (% of total fuel combustion) of United Kingdom in 1992 to that in 1993?
Make the answer very short. 0.97. What is the ratio of the CO2 emissions (% of total fuel combustion) of Croatia in 1992 to that in 1994?
Your response must be concise. 0.99. What is the ratio of the CO2 emissions (% of total fuel combustion) in Ghana in 1992 to that in 1994?
Your response must be concise. 0.95. What is the ratio of the CO2 emissions (% of total fuel combustion) in Poland in 1992 to that in 1994?
Provide a succinct answer. 0.77. What is the ratio of the CO2 emissions (% of total fuel combustion) in United Kingdom in 1992 to that in 1994?
Ensure brevity in your answer.  1.45. What is the ratio of the CO2 emissions (% of total fuel combustion) of Croatia in 1992 to that in 1995?
Keep it short and to the point. 1.15. What is the ratio of the CO2 emissions (% of total fuel combustion) of Ghana in 1992 to that in 1995?
Your response must be concise. 0.87. What is the ratio of the CO2 emissions (% of total fuel combustion) in Poland in 1992 to that in 1995?
Give a very brief answer. 0.79. What is the ratio of the CO2 emissions (% of total fuel combustion) of United Kingdom in 1992 to that in 1995?
Your response must be concise. 1.22. What is the ratio of the CO2 emissions (% of total fuel combustion) of Croatia in 1993 to that in 1994?
Your answer should be very brief. 0.95. What is the ratio of the CO2 emissions (% of total fuel combustion) of Ghana in 1993 to that in 1994?
Keep it short and to the point. 0.95. What is the ratio of the CO2 emissions (% of total fuel combustion) of Poland in 1993 to that in 1994?
Make the answer very short. 0.91. What is the ratio of the CO2 emissions (% of total fuel combustion) of United Kingdom in 1993 to that in 1994?
Offer a terse response. 1.49. What is the ratio of the CO2 emissions (% of total fuel combustion) of Croatia in 1993 to that in 1995?
Provide a short and direct response. 1.11. What is the ratio of the CO2 emissions (% of total fuel combustion) of Ghana in 1993 to that in 1995?
Your response must be concise. 0.88. What is the ratio of the CO2 emissions (% of total fuel combustion) of Poland in 1993 to that in 1995?
Make the answer very short. 0.93. What is the ratio of the CO2 emissions (% of total fuel combustion) in United Kingdom in 1993 to that in 1995?
Provide a succinct answer. 1.25. What is the ratio of the CO2 emissions (% of total fuel combustion) of Croatia in 1994 to that in 1995?
Your response must be concise. 1.16. What is the ratio of the CO2 emissions (% of total fuel combustion) in Ghana in 1994 to that in 1995?
Ensure brevity in your answer.  0.92. What is the ratio of the CO2 emissions (% of total fuel combustion) in Poland in 1994 to that in 1995?
Provide a succinct answer. 1.02. What is the ratio of the CO2 emissions (% of total fuel combustion) in United Kingdom in 1994 to that in 1995?
Give a very brief answer. 0.84. What is the difference between the highest and the second highest CO2 emissions (% of total fuel combustion) in Croatia?
Provide a succinct answer. 1.29. What is the difference between the highest and the second highest CO2 emissions (% of total fuel combustion) in Ghana?
Keep it short and to the point. 0.47. What is the difference between the highest and the second highest CO2 emissions (% of total fuel combustion) in Poland?
Provide a succinct answer. 0.09. What is the difference between the highest and the second highest CO2 emissions (% of total fuel combustion) of United Kingdom?
Keep it short and to the point. 0.32. What is the difference between the highest and the lowest CO2 emissions (% of total fuel combustion) of Croatia?
Keep it short and to the point. 2.28. What is the difference between the highest and the lowest CO2 emissions (% of total fuel combustion) in Ghana?
Offer a very short reply. 1.61. What is the difference between the highest and the lowest CO2 emissions (% of total fuel combustion) in Poland?
Provide a short and direct response. 1.79. What is the difference between the highest and the lowest CO2 emissions (% of total fuel combustion) of United Kingdom?
Give a very brief answer. 1.18. 